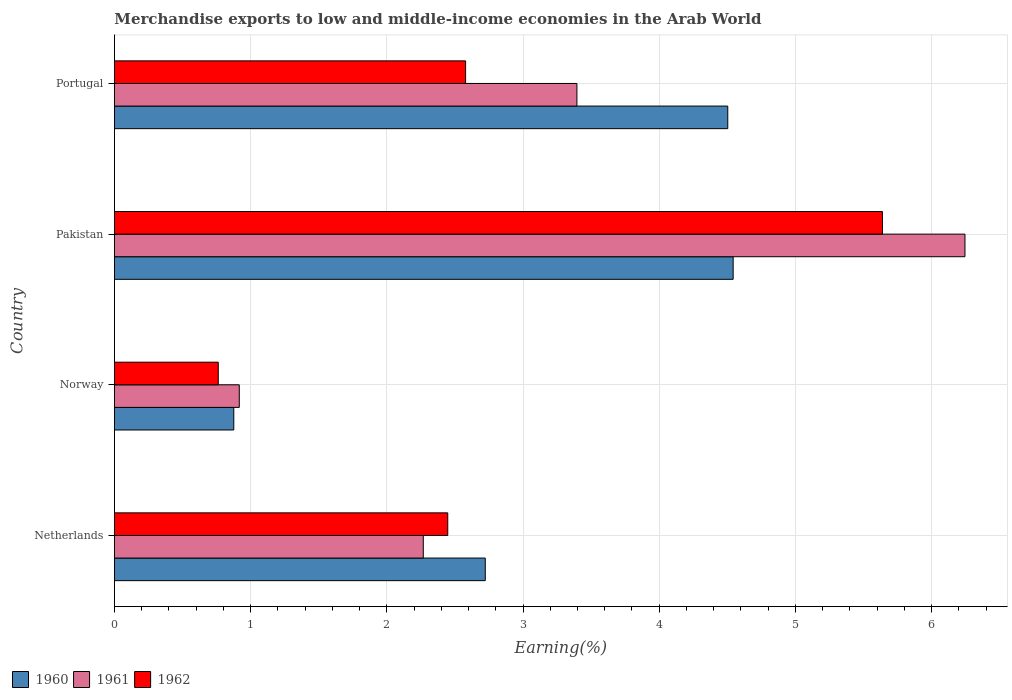Are the number of bars per tick equal to the number of legend labels?
Give a very brief answer. Yes. What is the label of the 1st group of bars from the top?
Offer a terse response. Portugal. In how many cases, is the number of bars for a given country not equal to the number of legend labels?
Provide a succinct answer. 0. What is the percentage of amount earned from merchandise exports in 1961 in Norway?
Your answer should be compact. 0.92. Across all countries, what is the maximum percentage of amount earned from merchandise exports in 1960?
Provide a short and direct response. 4.54. Across all countries, what is the minimum percentage of amount earned from merchandise exports in 1962?
Ensure brevity in your answer.  0.76. What is the total percentage of amount earned from merchandise exports in 1961 in the graph?
Offer a terse response. 12.83. What is the difference between the percentage of amount earned from merchandise exports in 1962 in Netherlands and that in Portugal?
Provide a succinct answer. -0.13. What is the difference between the percentage of amount earned from merchandise exports in 1961 in Norway and the percentage of amount earned from merchandise exports in 1960 in Portugal?
Give a very brief answer. -3.59. What is the average percentage of amount earned from merchandise exports in 1962 per country?
Your response must be concise. 2.86. What is the difference between the percentage of amount earned from merchandise exports in 1960 and percentage of amount earned from merchandise exports in 1962 in Norway?
Keep it short and to the point. 0.11. What is the ratio of the percentage of amount earned from merchandise exports in 1962 in Norway to that in Pakistan?
Ensure brevity in your answer.  0.14. Is the percentage of amount earned from merchandise exports in 1960 in Netherlands less than that in Portugal?
Give a very brief answer. Yes. Is the difference between the percentage of amount earned from merchandise exports in 1960 in Norway and Pakistan greater than the difference between the percentage of amount earned from merchandise exports in 1962 in Norway and Pakistan?
Offer a very short reply. Yes. What is the difference between the highest and the second highest percentage of amount earned from merchandise exports in 1960?
Ensure brevity in your answer.  0.04. What is the difference between the highest and the lowest percentage of amount earned from merchandise exports in 1961?
Offer a terse response. 5.33. How many bars are there?
Your response must be concise. 12. Are all the bars in the graph horizontal?
Your response must be concise. Yes. How many countries are there in the graph?
Give a very brief answer. 4. What is the difference between two consecutive major ticks on the X-axis?
Offer a terse response. 1. Are the values on the major ticks of X-axis written in scientific E-notation?
Keep it short and to the point. No. Where does the legend appear in the graph?
Your response must be concise. Bottom left. What is the title of the graph?
Your answer should be very brief. Merchandise exports to low and middle-income economies in the Arab World. What is the label or title of the X-axis?
Your response must be concise. Earning(%). What is the label or title of the Y-axis?
Make the answer very short. Country. What is the Earning(%) of 1960 in Netherlands?
Give a very brief answer. 2.72. What is the Earning(%) of 1961 in Netherlands?
Your response must be concise. 2.27. What is the Earning(%) in 1962 in Netherlands?
Your answer should be compact. 2.45. What is the Earning(%) in 1960 in Norway?
Your response must be concise. 0.88. What is the Earning(%) of 1961 in Norway?
Ensure brevity in your answer.  0.92. What is the Earning(%) in 1962 in Norway?
Your answer should be compact. 0.76. What is the Earning(%) of 1960 in Pakistan?
Your answer should be very brief. 4.54. What is the Earning(%) of 1961 in Pakistan?
Your response must be concise. 6.25. What is the Earning(%) of 1962 in Pakistan?
Your answer should be very brief. 5.64. What is the Earning(%) in 1960 in Portugal?
Your answer should be very brief. 4.5. What is the Earning(%) in 1961 in Portugal?
Keep it short and to the point. 3.4. What is the Earning(%) in 1962 in Portugal?
Offer a very short reply. 2.58. Across all countries, what is the maximum Earning(%) of 1960?
Keep it short and to the point. 4.54. Across all countries, what is the maximum Earning(%) of 1961?
Give a very brief answer. 6.25. Across all countries, what is the maximum Earning(%) in 1962?
Keep it short and to the point. 5.64. Across all countries, what is the minimum Earning(%) in 1960?
Your answer should be compact. 0.88. Across all countries, what is the minimum Earning(%) of 1961?
Offer a terse response. 0.92. Across all countries, what is the minimum Earning(%) in 1962?
Offer a terse response. 0.76. What is the total Earning(%) of 1960 in the graph?
Provide a succinct answer. 12.65. What is the total Earning(%) of 1961 in the graph?
Offer a very short reply. 12.83. What is the total Earning(%) in 1962 in the graph?
Ensure brevity in your answer.  11.43. What is the difference between the Earning(%) of 1960 in Netherlands and that in Norway?
Offer a terse response. 1.85. What is the difference between the Earning(%) in 1961 in Netherlands and that in Norway?
Offer a very short reply. 1.35. What is the difference between the Earning(%) of 1962 in Netherlands and that in Norway?
Offer a terse response. 1.68. What is the difference between the Earning(%) of 1960 in Netherlands and that in Pakistan?
Ensure brevity in your answer.  -1.82. What is the difference between the Earning(%) in 1961 in Netherlands and that in Pakistan?
Provide a short and direct response. -3.98. What is the difference between the Earning(%) of 1962 in Netherlands and that in Pakistan?
Provide a succinct answer. -3.19. What is the difference between the Earning(%) of 1960 in Netherlands and that in Portugal?
Give a very brief answer. -1.78. What is the difference between the Earning(%) of 1961 in Netherlands and that in Portugal?
Provide a succinct answer. -1.13. What is the difference between the Earning(%) of 1962 in Netherlands and that in Portugal?
Make the answer very short. -0.13. What is the difference between the Earning(%) in 1960 in Norway and that in Pakistan?
Keep it short and to the point. -3.67. What is the difference between the Earning(%) in 1961 in Norway and that in Pakistan?
Make the answer very short. -5.33. What is the difference between the Earning(%) in 1962 in Norway and that in Pakistan?
Provide a succinct answer. -4.88. What is the difference between the Earning(%) in 1960 in Norway and that in Portugal?
Give a very brief answer. -3.63. What is the difference between the Earning(%) in 1961 in Norway and that in Portugal?
Offer a very short reply. -2.48. What is the difference between the Earning(%) of 1962 in Norway and that in Portugal?
Your response must be concise. -1.82. What is the difference between the Earning(%) in 1960 in Pakistan and that in Portugal?
Provide a succinct answer. 0.04. What is the difference between the Earning(%) in 1961 in Pakistan and that in Portugal?
Your answer should be very brief. 2.85. What is the difference between the Earning(%) of 1962 in Pakistan and that in Portugal?
Offer a very short reply. 3.06. What is the difference between the Earning(%) in 1960 in Netherlands and the Earning(%) in 1961 in Norway?
Your answer should be very brief. 1.81. What is the difference between the Earning(%) in 1960 in Netherlands and the Earning(%) in 1962 in Norway?
Ensure brevity in your answer.  1.96. What is the difference between the Earning(%) of 1961 in Netherlands and the Earning(%) of 1962 in Norway?
Your answer should be very brief. 1.51. What is the difference between the Earning(%) in 1960 in Netherlands and the Earning(%) in 1961 in Pakistan?
Your answer should be compact. -3.52. What is the difference between the Earning(%) of 1960 in Netherlands and the Earning(%) of 1962 in Pakistan?
Your answer should be compact. -2.92. What is the difference between the Earning(%) of 1961 in Netherlands and the Earning(%) of 1962 in Pakistan?
Keep it short and to the point. -3.37. What is the difference between the Earning(%) of 1960 in Netherlands and the Earning(%) of 1961 in Portugal?
Your response must be concise. -0.67. What is the difference between the Earning(%) in 1960 in Netherlands and the Earning(%) in 1962 in Portugal?
Provide a short and direct response. 0.14. What is the difference between the Earning(%) of 1961 in Netherlands and the Earning(%) of 1962 in Portugal?
Offer a very short reply. -0.31. What is the difference between the Earning(%) of 1960 in Norway and the Earning(%) of 1961 in Pakistan?
Make the answer very short. -5.37. What is the difference between the Earning(%) in 1960 in Norway and the Earning(%) in 1962 in Pakistan?
Ensure brevity in your answer.  -4.76. What is the difference between the Earning(%) in 1961 in Norway and the Earning(%) in 1962 in Pakistan?
Make the answer very short. -4.72. What is the difference between the Earning(%) in 1960 in Norway and the Earning(%) in 1961 in Portugal?
Offer a terse response. -2.52. What is the difference between the Earning(%) in 1960 in Norway and the Earning(%) in 1962 in Portugal?
Your response must be concise. -1.7. What is the difference between the Earning(%) in 1961 in Norway and the Earning(%) in 1962 in Portugal?
Keep it short and to the point. -1.66. What is the difference between the Earning(%) in 1960 in Pakistan and the Earning(%) in 1961 in Portugal?
Your answer should be very brief. 1.15. What is the difference between the Earning(%) of 1960 in Pakistan and the Earning(%) of 1962 in Portugal?
Keep it short and to the point. 1.96. What is the difference between the Earning(%) in 1961 in Pakistan and the Earning(%) in 1962 in Portugal?
Your answer should be compact. 3.67. What is the average Earning(%) of 1960 per country?
Give a very brief answer. 3.16. What is the average Earning(%) of 1961 per country?
Your answer should be compact. 3.21. What is the average Earning(%) of 1962 per country?
Make the answer very short. 2.86. What is the difference between the Earning(%) in 1960 and Earning(%) in 1961 in Netherlands?
Ensure brevity in your answer.  0.46. What is the difference between the Earning(%) of 1960 and Earning(%) of 1962 in Netherlands?
Provide a succinct answer. 0.28. What is the difference between the Earning(%) in 1961 and Earning(%) in 1962 in Netherlands?
Provide a short and direct response. -0.18. What is the difference between the Earning(%) of 1960 and Earning(%) of 1961 in Norway?
Your answer should be compact. -0.04. What is the difference between the Earning(%) in 1960 and Earning(%) in 1962 in Norway?
Provide a succinct answer. 0.11. What is the difference between the Earning(%) in 1961 and Earning(%) in 1962 in Norway?
Make the answer very short. 0.15. What is the difference between the Earning(%) of 1960 and Earning(%) of 1961 in Pakistan?
Make the answer very short. -1.7. What is the difference between the Earning(%) in 1960 and Earning(%) in 1962 in Pakistan?
Your response must be concise. -1.1. What is the difference between the Earning(%) of 1961 and Earning(%) of 1962 in Pakistan?
Your response must be concise. 0.61. What is the difference between the Earning(%) of 1960 and Earning(%) of 1961 in Portugal?
Provide a succinct answer. 1.11. What is the difference between the Earning(%) in 1960 and Earning(%) in 1962 in Portugal?
Ensure brevity in your answer.  1.93. What is the difference between the Earning(%) of 1961 and Earning(%) of 1962 in Portugal?
Your answer should be compact. 0.82. What is the ratio of the Earning(%) of 1960 in Netherlands to that in Norway?
Keep it short and to the point. 3.11. What is the ratio of the Earning(%) of 1961 in Netherlands to that in Norway?
Provide a short and direct response. 2.47. What is the ratio of the Earning(%) in 1962 in Netherlands to that in Norway?
Keep it short and to the point. 3.21. What is the ratio of the Earning(%) of 1960 in Netherlands to that in Pakistan?
Provide a succinct answer. 0.6. What is the ratio of the Earning(%) of 1961 in Netherlands to that in Pakistan?
Keep it short and to the point. 0.36. What is the ratio of the Earning(%) of 1962 in Netherlands to that in Pakistan?
Ensure brevity in your answer.  0.43. What is the ratio of the Earning(%) in 1960 in Netherlands to that in Portugal?
Your answer should be compact. 0.6. What is the ratio of the Earning(%) in 1961 in Netherlands to that in Portugal?
Your response must be concise. 0.67. What is the ratio of the Earning(%) of 1962 in Netherlands to that in Portugal?
Your answer should be very brief. 0.95. What is the ratio of the Earning(%) in 1960 in Norway to that in Pakistan?
Your answer should be compact. 0.19. What is the ratio of the Earning(%) of 1961 in Norway to that in Pakistan?
Give a very brief answer. 0.15. What is the ratio of the Earning(%) in 1962 in Norway to that in Pakistan?
Make the answer very short. 0.14. What is the ratio of the Earning(%) of 1960 in Norway to that in Portugal?
Offer a terse response. 0.19. What is the ratio of the Earning(%) of 1961 in Norway to that in Portugal?
Keep it short and to the point. 0.27. What is the ratio of the Earning(%) in 1962 in Norway to that in Portugal?
Offer a very short reply. 0.3. What is the ratio of the Earning(%) in 1960 in Pakistan to that in Portugal?
Give a very brief answer. 1.01. What is the ratio of the Earning(%) of 1961 in Pakistan to that in Portugal?
Your response must be concise. 1.84. What is the ratio of the Earning(%) of 1962 in Pakistan to that in Portugal?
Ensure brevity in your answer.  2.19. What is the difference between the highest and the second highest Earning(%) in 1960?
Offer a terse response. 0.04. What is the difference between the highest and the second highest Earning(%) in 1961?
Your answer should be compact. 2.85. What is the difference between the highest and the second highest Earning(%) of 1962?
Offer a terse response. 3.06. What is the difference between the highest and the lowest Earning(%) of 1960?
Offer a very short reply. 3.67. What is the difference between the highest and the lowest Earning(%) in 1961?
Your response must be concise. 5.33. What is the difference between the highest and the lowest Earning(%) in 1962?
Offer a very short reply. 4.88. 